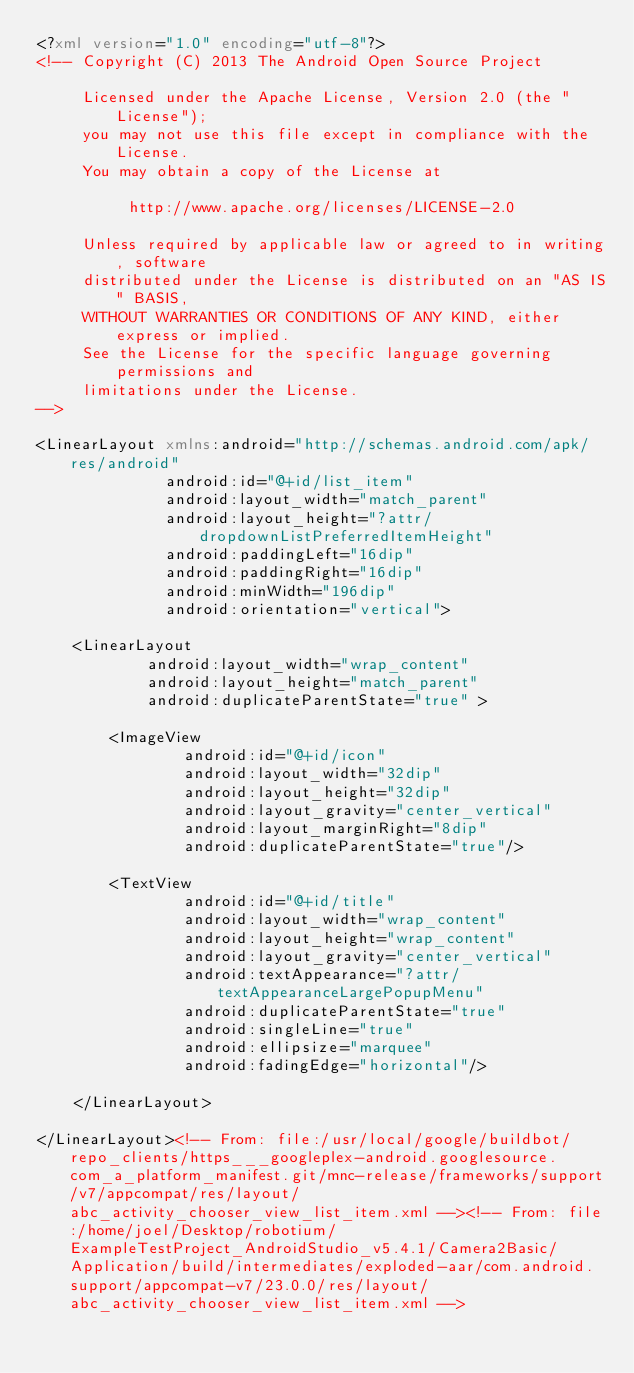Convert code to text. <code><loc_0><loc_0><loc_500><loc_500><_XML_><?xml version="1.0" encoding="utf-8"?>
<!-- Copyright (C) 2013 The Android Open Source Project

     Licensed under the Apache License, Version 2.0 (the "License");
     you may not use this file except in compliance with the License.
     You may obtain a copy of the License at

          http://www.apache.org/licenses/LICENSE-2.0

     Unless required by applicable law or agreed to in writing, software
     distributed under the License is distributed on an "AS IS" BASIS,
     WITHOUT WARRANTIES OR CONDITIONS OF ANY KIND, either express or implied.
     See the License for the specific language governing permissions and
     limitations under the License.
-->

<LinearLayout xmlns:android="http://schemas.android.com/apk/res/android"
              android:id="@+id/list_item"
              android:layout_width="match_parent"
              android:layout_height="?attr/dropdownListPreferredItemHeight"
              android:paddingLeft="16dip"
              android:paddingRight="16dip"
              android:minWidth="196dip"
              android:orientation="vertical">

    <LinearLayout
            android:layout_width="wrap_content"
            android:layout_height="match_parent"
            android:duplicateParentState="true" >

        <ImageView
                android:id="@+id/icon"
                android:layout_width="32dip"
                android:layout_height="32dip"
                android:layout_gravity="center_vertical"
                android:layout_marginRight="8dip"
                android:duplicateParentState="true"/>

        <TextView
                android:id="@+id/title"
                android:layout_width="wrap_content"
                android:layout_height="wrap_content"
                android:layout_gravity="center_vertical"
                android:textAppearance="?attr/textAppearanceLargePopupMenu"
                android:duplicateParentState="true"
                android:singleLine="true"
                android:ellipsize="marquee"
                android:fadingEdge="horizontal"/>

    </LinearLayout>

</LinearLayout><!-- From: file:/usr/local/google/buildbot/repo_clients/https___googleplex-android.googlesource.com_a_platform_manifest.git/mnc-release/frameworks/support/v7/appcompat/res/layout/abc_activity_chooser_view_list_item.xml --><!-- From: file:/home/joel/Desktop/robotium/ExampleTestProject_AndroidStudio_v5.4.1/Camera2Basic/Application/build/intermediates/exploded-aar/com.android.support/appcompat-v7/23.0.0/res/layout/abc_activity_chooser_view_list_item.xml --></code> 